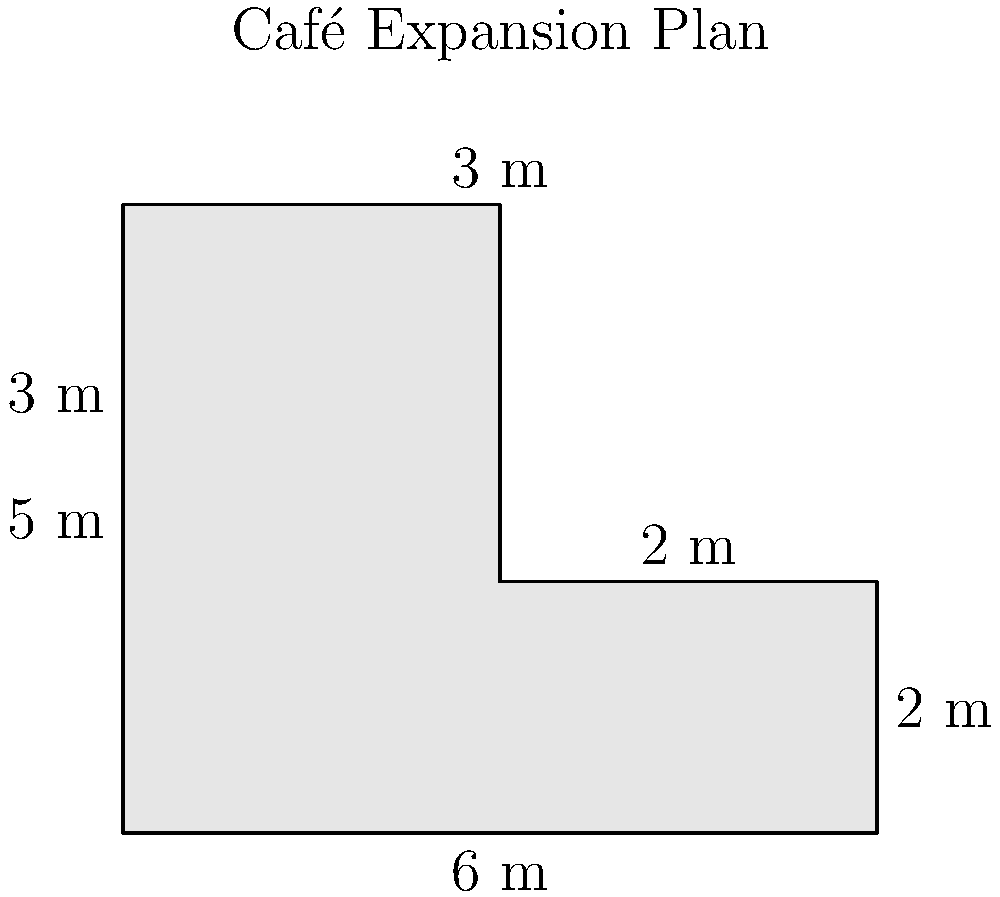You're planning to expand your café into an L-shaped area. The expansion consists of two rectangular sections: one measuring 6 m by 2 m, and another measuring 3 m by 5 m. What is the total area of the expanded space in square meters? To find the total area of the L-shaped expansion, we need to calculate the areas of both rectangular sections and add them together.

1. Calculate the area of the first rectangular section:
   Length = 6 m, Width = 2 m
   Area of first section = $6 \text{ m} \times 2 \text{ m} = 12 \text{ m}^2$

2. Calculate the area of the second rectangular section:
   Length = 3 m, Width = 5 m
   Area of second section = $3 \text{ m} \times 5 \text{ m} = 15 \text{ m}^2$

3. Sum up the areas of both sections:
   Total area = Area of first section + Area of second section
   Total area = $12 \text{ m}^2 + 15 \text{ m}^2 = 27 \text{ m}^2$

Therefore, the total area of the expanded café space is 27 square meters.
Answer: $27 \text{ m}^2$ 